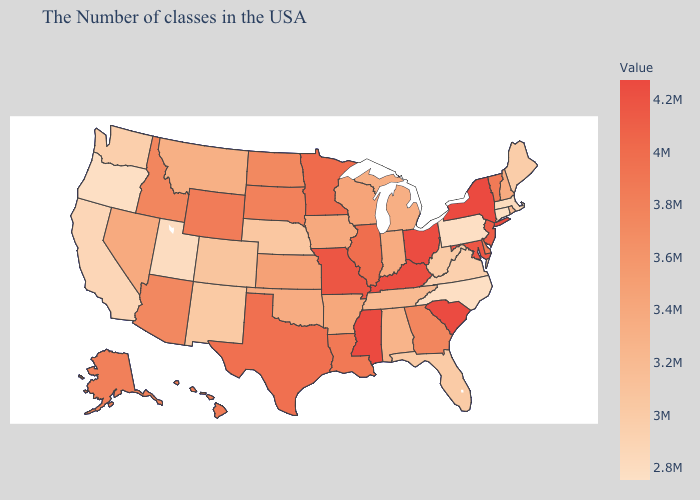Which states have the highest value in the USA?
Be succinct. New York. Is the legend a continuous bar?
Concise answer only. Yes. Among the states that border Montana , which have the highest value?
Answer briefly. Wyoming. Among the states that border North Dakota , does Minnesota have the lowest value?
Quick response, please. No. Which states have the lowest value in the USA?
Give a very brief answer. Connecticut. Does the map have missing data?
Write a very short answer. No. 